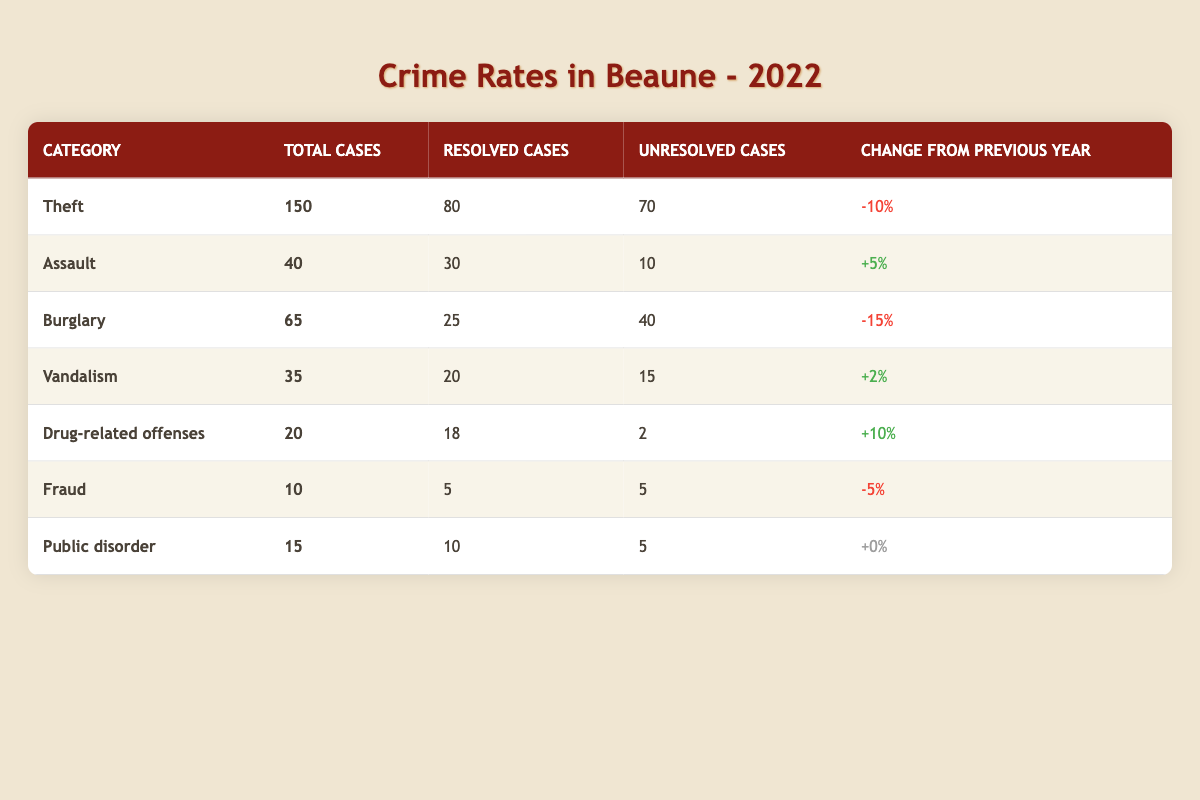What is the total number of Theft cases in Beaune for 2022? The table shows that the total number of Theft cases in 2022 is clearly stated as 150.
Answer: 150 How many cases of Assault were resolved in 2022? From the table, we can see that 30 cases of Assault were resolved in 2022.
Answer: 30 What is the percentage change in Burglary cases from the previous year? The table indicates that there was a -15% change in Burglary cases from the previous year.
Answer: -15% Which category had the highest number of unresolved cases in 2022? Looking through the unresolved cases column, Theft had the highest at 70 unresolved cases.
Answer: Theft How many total cases were reported for Drug-related offenses in 2022? The total number of cases reported for Drug-related offenses, as per the table, is 20.
Answer: 20 What is the total number of resolved cases across all categories? By adding the resolved cases: 80 (Theft) + 30 (Assault) + 25 (Burglary) + 20 (Vandalism) + 18 (Drug-related offenses) + 5 (Fraud) + 10 (Public disorder) = 188.
Answer: 188 What is the difference in total cases between Theft and Burglary? The number of cases for Theft is 150, and for Burglary, it is 65. The difference is 150 - 65 = 85.
Answer: 85 Did the number of Drug-related offenses cases increase or decrease compared to the previous year? The table shows an increase of +10% for Drug-related offenses, indicating it increased compared to the previous year.
Answer: Yes Which category saw a decrease in cases compared to the previous year besides Theft? The table indicates that Burglary also saw a decrease of -15%, in addition to Theft's -10%.
Answer: Burglary What percentage of total Assault cases were resolved in 2022? To find the percentage of resolved cases for Assault: (30 resolved / 40 total cases) * 100 = 75%.
Answer: 75% What is the ratio of unresolved cases to total cases in the Vandalism category? The total cases of Vandalism are 35, with 15 unresolved cases. The ratio of unresolved to total cases is 15:35, which simplifies to 3:7.
Answer: 3:7 Which category had the least number of total cases? The category with the least number of total cases is Fraud, with only 10 cases reported.
Answer: Fraud 